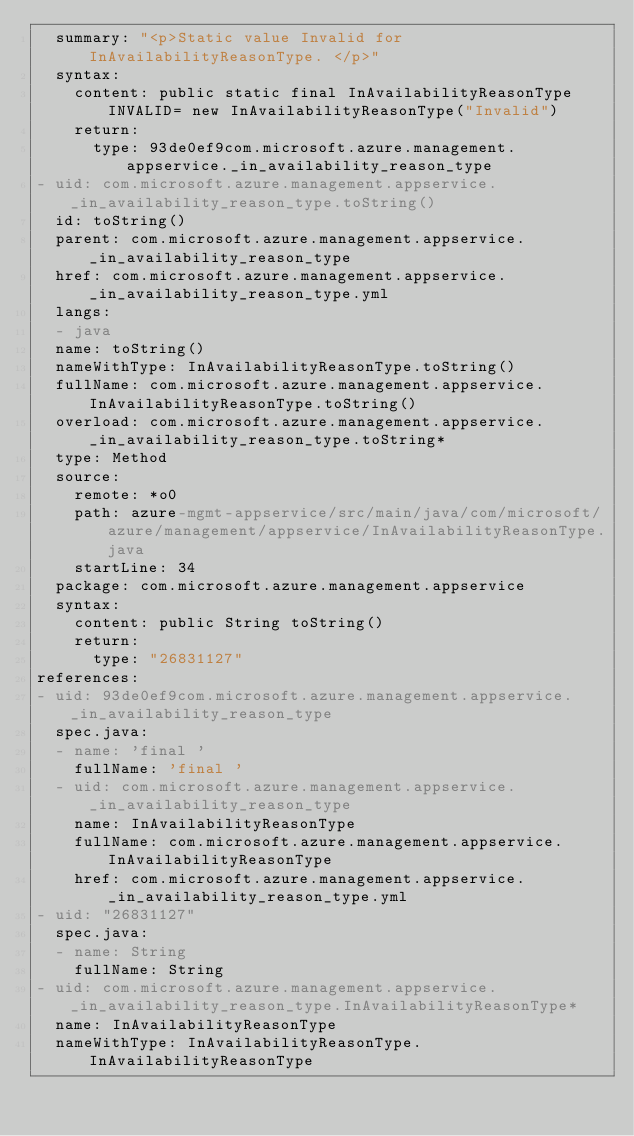<code> <loc_0><loc_0><loc_500><loc_500><_YAML_>  summary: "<p>Static value Invalid for InAvailabilityReasonType. </p>"
  syntax:
    content: public static final InAvailabilityReasonType INVALID= new InAvailabilityReasonType("Invalid")
    return:
      type: 93de0ef9com.microsoft.azure.management.appservice._in_availability_reason_type
- uid: com.microsoft.azure.management.appservice._in_availability_reason_type.toString()
  id: toString()
  parent: com.microsoft.azure.management.appservice._in_availability_reason_type
  href: com.microsoft.azure.management.appservice._in_availability_reason_type.yml
  langs:
  - java
  name: toString()
  nameWithType: InAvailabilityReasonType.toString()
  fullName: com.microsoft.azure.management.appservice.InAvailabilityReasonType.toString()
  overload: com.microsoft.azure.management.appservice._in_availability_reason_type.toString*
  type: Method
  source:
    remote: *o0
    path: azure-mgmt-appservice/src/main/java/com/microsoft/azure/management/appservice/InAvailabilityReasonType.java
    startLine: 34
  package: com.microsoft.azure.management.appservice
  syntax:
    content: public String toString()
    return:
      type: "26831127"
references:
- uid: 93de0ef9com.microsoft.azure.management.appservice._in_availability_reason_type
  spec.java:
  - name: 'final '
    fullName: 'final '
  - uid: com.microsoft.azure.management.appservice._in_availability_reason_type
    name: InAvailabilityReasonType
    fullName: com.microsoft.azure.management.appservice.InAvailabilityReasonType
    href: com.microsoft.azure.management.appservice._in_availability_reason_type.yml
- uid: "26831127"
  spec.java:
  - name: String
    fullName: String
- uid: com.microsoft.azure.management.appservice._in_availability_reason_type.InAvailabilityReasonType*
  name: InAvailabilityReasonType
  nameWithType: InAvailabilityReasonType.InAvailabilityReasonType</code> 